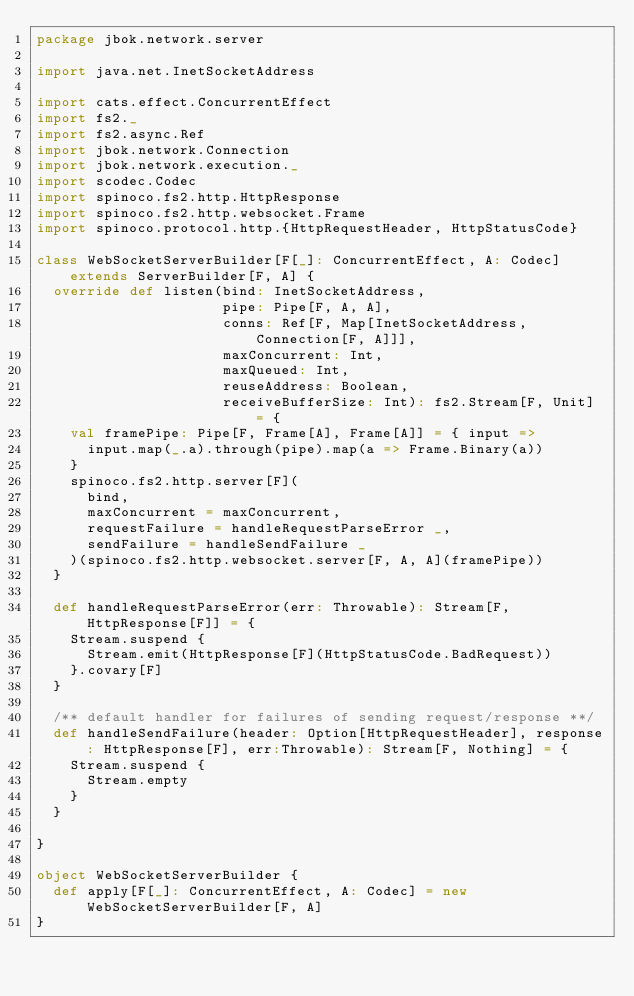<code> <loc_0><loc_0><loc_500><loc_500><_Scala_>package jbok.network.server

import java.net.InetSocketAddress

import cats.effect.ConcurrentEffect
import fs2._
import fs2.async.Ref
import jbok.network.Connection
import jbok.network.execution._
import scodec.Codec
import spinoco.fs2.http.HttpResponse
import spinoco.fs2.http.websocket.Frame
import spinoco.protocol.http.{HttpRequestHeader, HttpStatusCode}

class WebSocketServerBuilder[F[_]: ConcurrentEffect, A: Codec] extends ServerBuilder[F, A] {
  override def listen(bind: InetSocketAddress,
                      pipe: Pipe[F, A, A],
                      conns: Ref[F, Map[InetSocketAddress, Connection[F, A]]],
                      maxConcurrent: Int,
                      maxQueued: Int,
                      reuseAddress: Boolean,
                      receiveBufferSize: Int): fs2.Stream[F, Unit] = {
    val framePipe: Pipe[F, Frame[A], Frame[A]] = { input =>
      input.map(_.a).through(pipe).map(a => Frame.Binary(a))
    }
    spinoco.fs2.http.server[F](
      bind,
      maxConcurrent = maxConcurrent,
      requestFailure = handleRequestParseError _,
      sendFailure = handleSendFailure _
    )(spinoco.fs2.http.websocket.server[F, A, A](framePipe))
  }

  def handleRequestParseError(err: Throwable): Stream[F, HttpResponse[F]] = {
    Stream.suspend {
      Stream.emit(HttpResponse[F](HttpStatusCode.BadRequest))
    }.covary[F]
  }

  /** default handler for failures of sending request/response **/
  def handleSendFailure(header: Option[HttpRequestHeader], response: HttpResponse[F], err:Throwable): Stream[F, Nothing] = {
    Stream.suspend {
      Stream.empty
    }
  }

}

object WebSocketServerBuilder {
  def apply[F[_]: ConcurrentEffect, A: Codec] = new WebSocketServerBuilder[F, A]
}
</code> 